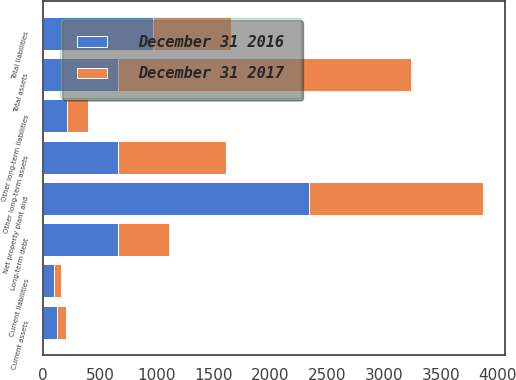<chart> <loc_0><loc_0><loc_500><loc_500><stacked_bar_chart><ecel><fcel>Current assets<fcel>Net property plant and<fcel>Other long-term assets<fcel>Total assets<fcel>Current liabilities<fcel>Long-term debt<fcel>Other long-term liabilities<fcel>Total liabilities<nl><fcel>December 31 2016<fcel>118<fcel>2337<fcel>658<fcel>658<fcel>96<fcel>661<fcel>209<fcel>966<nl><fcel>December 31 2017<fcel>87<fcel>1534<fcel>954<fcel>2575<fcel>59<fcel>442<fcel>183<fcel>684<nl></chart> 